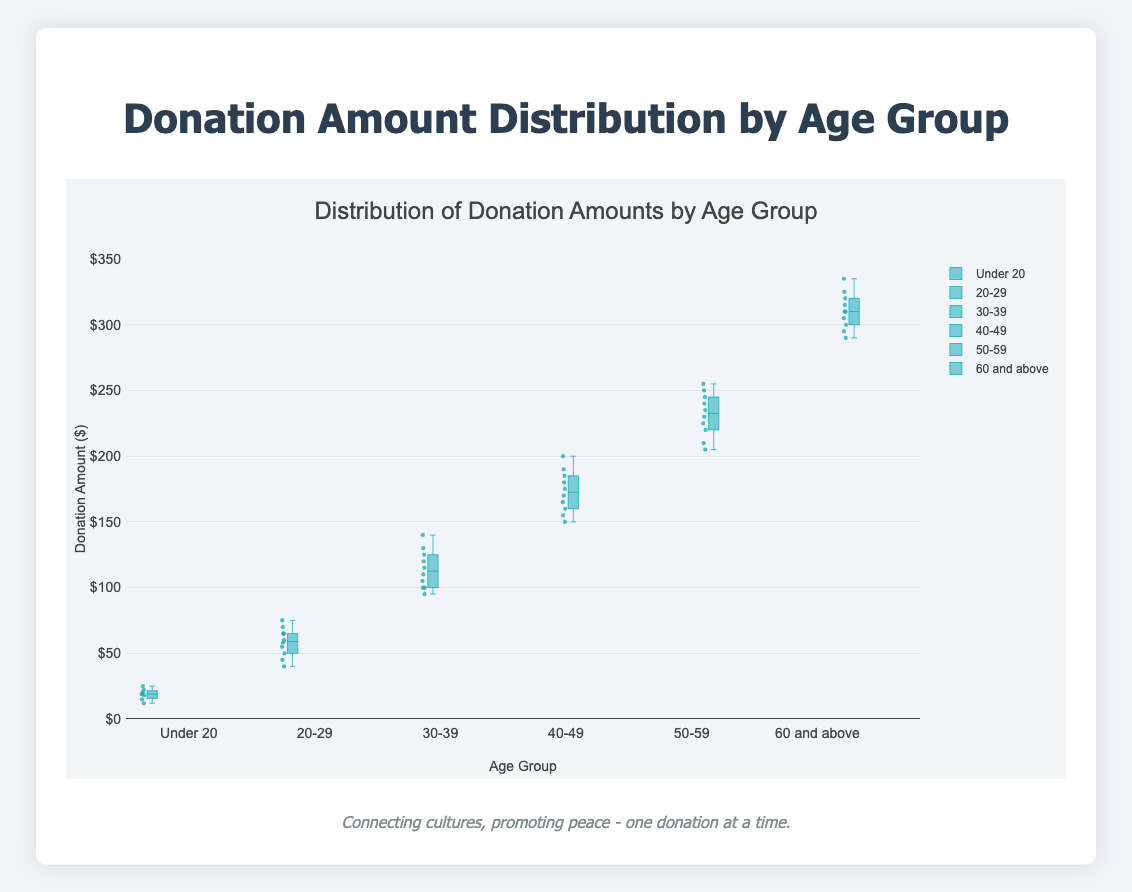How many age groups are represented in the box plot? The box plot represents the data segmented by age groups, and each group has a separate box plot. By visually identifying the number of distinct boxes on the x-axis, we count six age groups.
Answer: Six What's the median donation amount for the age group 40-49? The median value for each box plot is shown by the line inside the box. For the age group 40-49, this line indicates a donation amount of about $165.
Answer: $165 Which age group has the highest median donation amount? The median line is the central value inside each box. By comparing these lines across all age groups, the group "60 and above" has the highest median donation amount, around $310.
Answer: 60 and above What is the interquartile range (IQR) for the age group 20-29? The IQR is the range between the first quartile (Q1) and third quartile (Q3) values. For the age group 20-29, estimate Q1 and Q3 from the box plot (approximately $50 and $70 respectively). IQR = Q3 - Q1 = $70 - $50 = $20.
Answer: $20 How does the spread of donation amounts for the age group 50-59 compare to the age group Under 20? The spread of donation amounts is indicated by the length of the boxes and the whiskers. The age group 50-59 has a much larger spread (from about $205 to $255) compared to Under 20 (from about $12 to $25).
Answer: 50-59 has a larger spread What is the range of donation amounts for the age group 30-39? The range is the difference between the maximum and minimum values. For the age group 30-39, the minimum is around $95 and the maximum is around $140. Range = $140 - $95 = $45.
Answer: $45 Which age group shows the greatest variation in donation amounts? The greatest variation can be seen by comparing the lengths of the boxes (indicating IQR) and whiskers. The age group 60 and above shows the greatest variation, with values ranging approximately from $290 to $335.
Answer: 60 and above Do any age groups have outliers shown in the box plot? Outliers are shown as individual points outside the whiskers in a box plot. None of the boxes have points outside the whiskers, indicating no outliers for any age group.
Answer: No How do the donation amounts for the age group Under 20 compare with those of the age group 20-29 in terms of median and range? For Under 20, the median is about $19, and the range is $13. For 20-29, the median is about $60 and the range is $35. The age group 20-29 has a higher median and a larger range.
Answer: 20-29 has higher median and larger range 